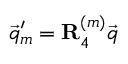<formula> <loc_0><loc_0><loc_500><loc_500>\vec { q } _ { m } ^ { \prime } = R _ { 4 } ^ { ( m ) } \vec { q }</formula> 